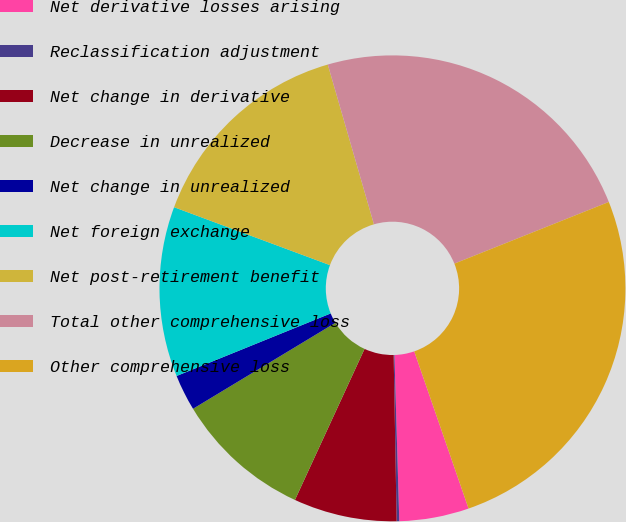<chart> <loc_0><loc_0><loc_500><loc_500><pie_chart><fcel>Net derivative losses arising<fcel>Reclassification adjustment<fcel>Net change in derivative<fcel>Decrease in unrealized<fcel>Net change in unrealized<fcel>Net foreign exchange<fcel>Net post-retirement benefit<fcel>Total other comprehensive loss<fcel>Other comprehensive loss<nl><fcel>4.83%<fcel>0.18%<fcel>7.16%<fcel>9.48%<fcel>2.51%<fcel>11.8%<fcel>14.86%<fcel>23.43%<fcel>25.75%<nl></chart> 